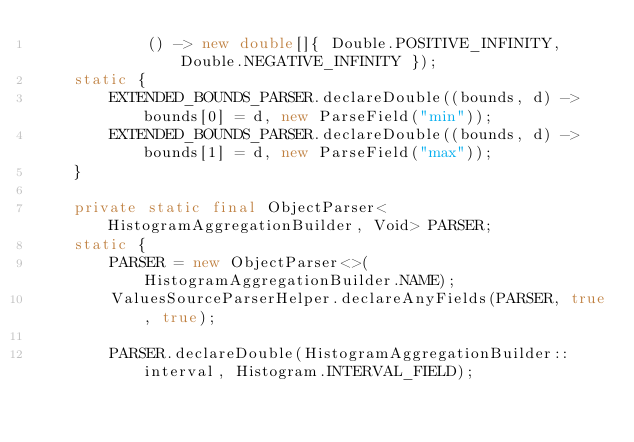Convert code to text. <code><loc_0><loc_0><loc_500><loc_500><_Java_>            () -> new double[]{ Double.POSITIVE_INFINITY, Double.NEGATIVE_INFINITY });
    static {
        EXTENDED_BOUNDS_PARSER.declareDouble((bounds, d) -> bounds[0] = d, new ParseField("min"));
        EXTENDED_BOUNDS_PARSER.declareDouble((bounds, d) -> bounds[1] = d, new ParseField("max"));
    }

    private static final ObjectParser<HistogramAggregationBuilder, Void> PARSER;
    static {
        PARSER = new ObjectParser<>(HistogramAggregationBuilder.NAME);
        ValuesSourceParserHelper.declareAnyFields(PARSER, true, true);

        PARSER.declareDouble(HistogramAggregationBuilder::interval, Histogram.INTERVAL_FIELD);
</code> 